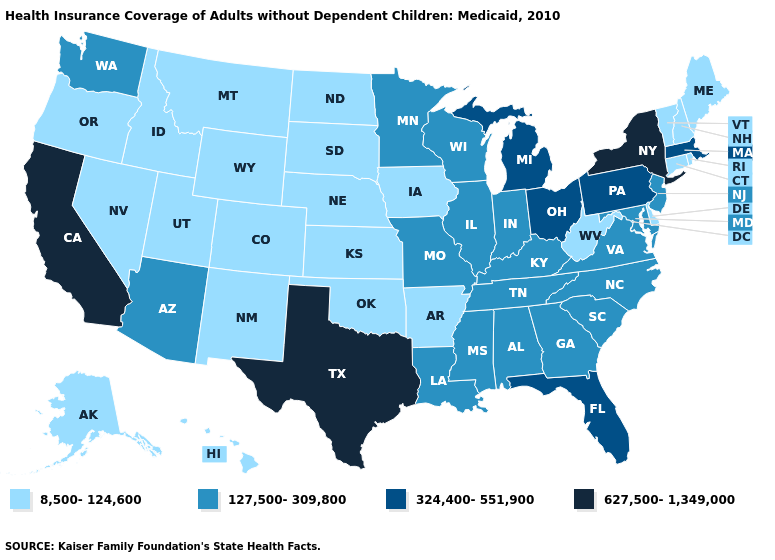What is the value of Arkansas?
Short answer required. 8,500-124,600. What is the lowest value in the USA?
Answer briefly. 8,500-124,600. What is the value of Minnesota?
Keep it brief. 127,500-309,800. What is the highest value in states that border South Carolina?
Quick response, please. 127,500-309,800. Name the states that have a value in the range 8,500-124,600?
Concise answer only. Alaska, Arkansas, Colorado, Connecticut, Delaware, Hawaii, Idaho, Iowa, Kansas, Maine, Montana, Nebraska, Nevada, New Hampshire, New Mexico, North Dakota, Oklahoma, Oregon, Rhode Island, South Dakota, Utah, Vermont, West Virginia, Wyoming. Does Washington have the highest value in the USA?
Short answer required. No. What is the value of Wyoming?
Keep it brief. 8,500-124,600. Does West Virginia have a lower value than Michigan?
Concise answer only. Yes. Which states have the highest value in the USA?
Short answer required. California, New York, Texas. Among the states that border Nebraska , does Missouri have the lowest value?
Give a very brief answer. No. What is the value of Louisiana?
Concise answer only. 127,500-309,800. What is the value of Delaware?
Answer briefly. 8,500-124,600. What is the value of Connecticut?
Give a very brief answer. 8,500-124,600. Name the states that have a value in the range 127,500-309,800?
Give a very brief answer. Alabama, Arizona, Georgia, Illinois, Indiana, Kentucky, Louisiana, Maryland, Minnesota, Mississippi, Missouri, New Jersey, North Carolina, South Carolina, Tennessee, Virginia, Washington, Wisconsin. Among the states that border Arizona , does California have the lowest value?
Be succinct. No. 